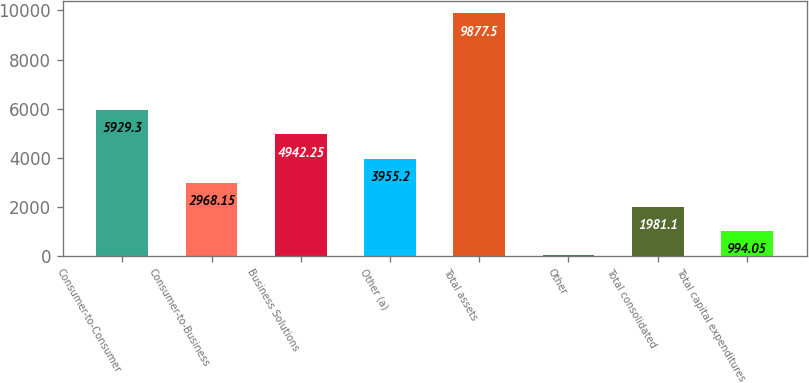Convert chart. <chart><loc_0><loc_0><loc_500><loc_500><bar_chart><fcel>Consumer-to-Consumer<fcel>Consumer-to-Business<fcel>Business Solutions<fcel>Other (a)<fcel>Total assets<fcel>Other<fcel>Total consolidated<fcel>Total capital expenditures<nl><fcel>5929.3<fcel>2968.15<fcel>4942.25<fcel>3955.2<fcel>9877.5<fcel>7<fcel>1981.1<fcel>994.05<nl></chart> 